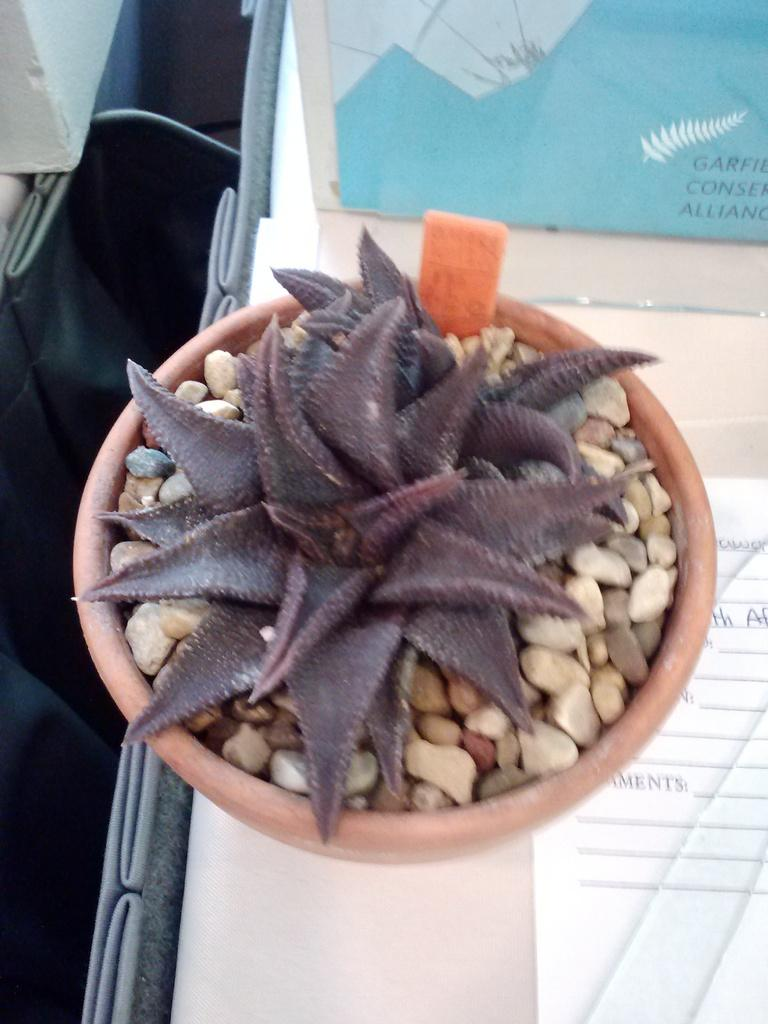What type of plant can be seen in the image? There is a house plant in the image. How is the house plant contained or supported? The house plant is in a pot. What is inside the pot with the plant? The pot contains stones. Where is the pot with the plant located? The pot with the plant is placed on a wall. What type of religious symbol is hanging on the wall next to the pot with the plant? There is no religious symbol present in the image; it only features a house plant in a pot with stones, placed on a wall. 